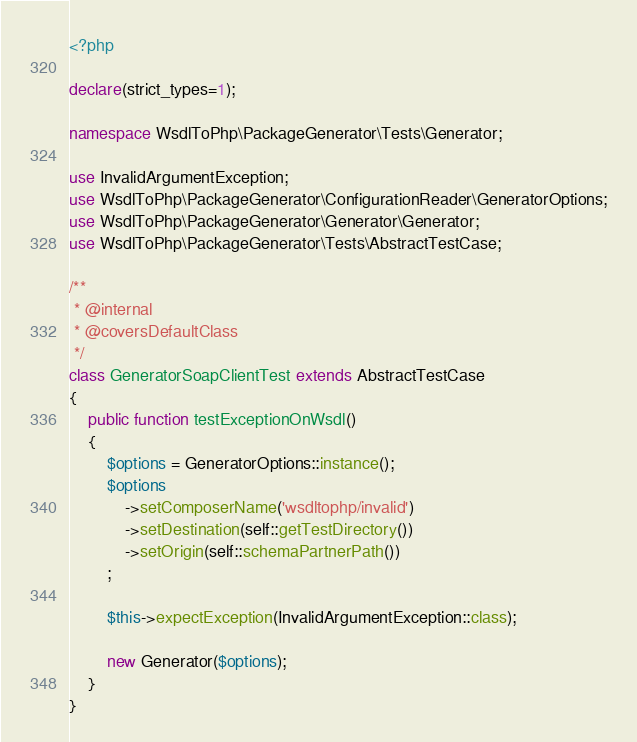<code> <loc_0><loc_0><loc_500><loc_500><_PHP_><?php

declare(strict_types=1);

namespace WsdlToPhp\PackageGenerator\Tests\Generator;

use InvalidArgumentException;
use WsdlToPhp\PackageGenerator\ConfigurationReader\GeneratorOptions;
use WsdlToPhp\PackageGenerator\Generator\Generator;
use WsdlToPhp\PackageGenerator\Tests\AbstractTestCase;

/**
 * @internal
 * @coversDefaultClass
 */
class GeneratorSoapClientTest extends AbstractTestCase
{
    public function testExceptionOnWsdl()
    {
        $options = GeneratorOptions::instance();
        $options
            ->setComposerName('wsdltophp/invalid')
            ->setDestination(self::getTestDirectory())
            ->setOrigin(self::schemaPartnerPath())
        ;

        $this->expectException(InvalidArgumentException::class);

        new Generator($options);
    }
}
</code> 